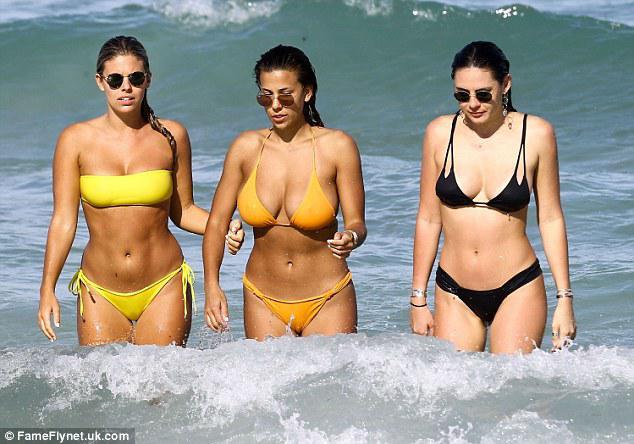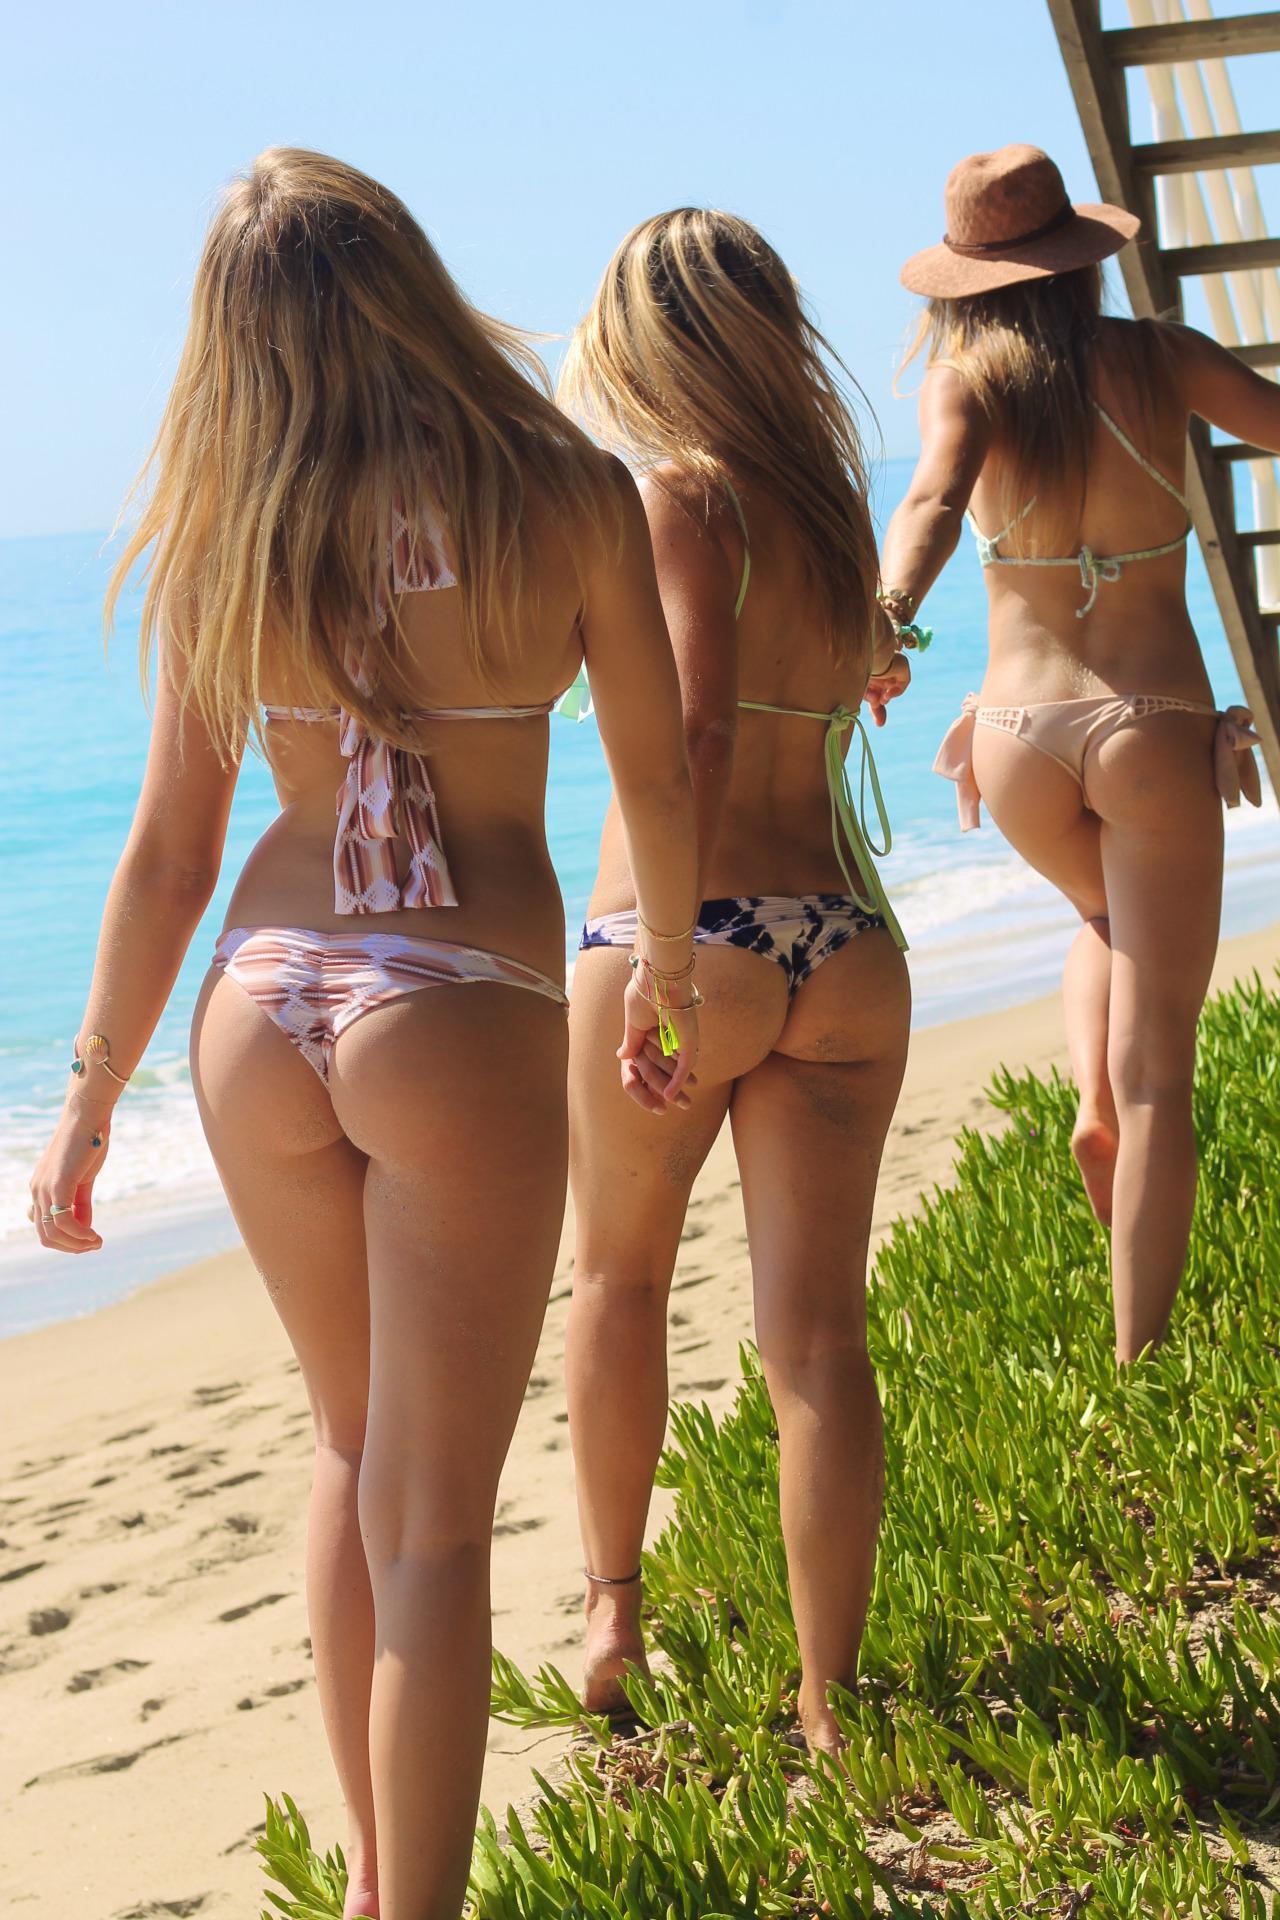The first image is the image on the left, the second image is the image on the right. For the images shown, is this caption "The three women in bikinis in the image on the right are shown from behind." true? Answer yes or no. Yes. The first image is the image on the left, the second image is the image on the right. Examine the images to the left and right. Is the description "An image shows three bikini models with their rears to the camera, standing with arms around each other." accurate? Answer yes or no. No. 